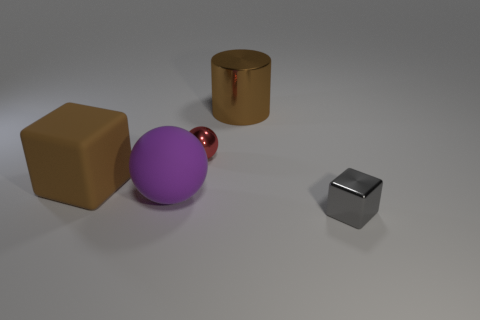Is the number of large purple things greater than the number of gray matte objects?
Ensure brevity in your answer.  Yes. The block that is made of the same material as the purple ball is what size?
Your response must be concise. Large. Do the cube that is right of the shiny cylinder and the block on the left side of the tiny gray shiny cube have the same size?
Provide a short and direct response. No. How many things are cubes right of the red ball or balls?
Provide a succinct answer. 3. Are there fewer small red matte things than large matte balls?
Ensure brevity in your answer.  Yes. The tiny metal thing that is left of the large brown object that is behind the cube that is behind the small metal cube is what shape?
Provide a succinct answer. Sphere. There is a metallic object that is the same color as the big cube; what is its shape?
Provide a short and direct response. Cylinder. Are there any big brown metallic objects?
Keep it short and to the point. Yes. There is a brown matte cube; is its size the same as the brown object that is right of the purple rubber sphere?
Your answer should be compact. Yes. Are there any brown shiny cylinders in front of the large brown thing that is left of the large metal thing?
Ensure brevity in your answer.  No. 